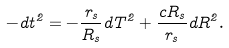Convert formula to latex. <formula><loc_0><loc_0><loc_500><loc_500>- d t ^ { 2 } = - \frac { r _ { s } } { R _ { s } } d T ^ { 2 } + \frac { c R _ { s } } { r _ { s } } d R ^ { 2 } .</formula> 